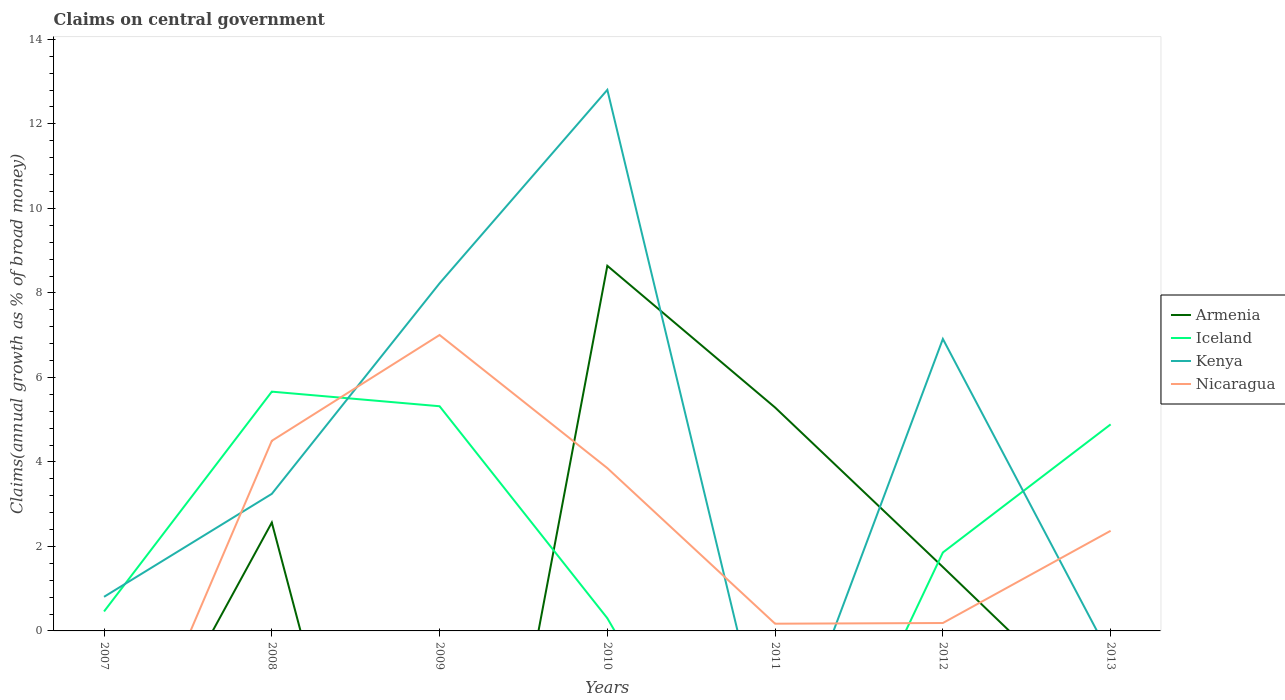How many different coloured lines are there?
Provide a succinct answer. 4. Across all years, what is the maximum percentage of broad money claimed on centeral government in Kenya?
Offer a terse response. 0. What is the total percentage of broad money claimed on centeral government in Nicaragua in the graph?
Your answer should be compact. -2.5. What is the difference between the highest and the second highest percentage of broad money claimed on centeral government in Iceland?
Offer a terse response. 5.66. Is the percentage of broad money claimed on centeral government in Kenya strictly greater than the percentage of broad money claimed on centeral government in Iceland over the years?
Give a very brief answer. No. How many lines are there?
Give a very brief answer. 4. How many years are there in the graph?
Make the answer very short. 7. What is the difference between two consecutive major ticks on the Y-axis?
Your answer should be very brief. 2. Are the values on the major ticks of Y-axis written in scientific E-notation?
Provide a succinct answer. No. Does the graph contain grids?
Give a very brief answer. No. How are the legend labels stacked?
Offer a very short reply. Vertical. What is the title of the graph?
Your response must be concise. Claims on central government. Does "Hungary" appear as one of the legend labels in the graph?
Your response must be concise. No. What is the label or title of the Y-axis?
Ensure brevity in your answer.  Claims(annual growth as % of broad money). What is the Claims(annual growth as % of broad money) in Iceland in 2007?
Offer a terse response. 0.46. What is the Claims(annual growth as % of broad money) in Kenya in 2007?
Offer a terse response. 0.81. What is the Claims(annual growth as % of broad money) in Armenia in 2008?
Keep it short and to the point. 2.57. What is the Claims(annual growth as % of broad money) in Iceland in 2008?
Offer a very short reply. 5.66. What is the Claims(annual growth as % of broad money) in Kenya in 2008?
Keep it short and to the point. 3.24. What is the Claims(annual growth as % of broad money) in Nicaragua in 2008?
Provide a short and direct response. 4.5. What is the Claims(annual growth as % of broad money) in Armenia in 2009?
Provide a short and direct response. 0. What is the Claims(annual growth as % of broad money) in Iceland in 2009?
Your answer should be very brief. 5.32. What is the Claims(annual growth as % of broad money) in Kenya in 2009?
Offer a very short reply. 8.23. What is the Claims(annual growth as % of broad money) in Nicaragua in 2009?
Give a very brief answer. 7. What is the Claims(annual growth as % of broad money) in Armenia in 2010?
Provide a short and direct response. 8.64. What is the Claims(annual growth as % of broad money) in Iceland in 2010?
Provide a succinct answer. 0.3. What is the Claims(annual growth as % of broad money) in Kenya in 2010?
Provide a succinct answer. 12.81. What is the Claims(annual growth as % of broad money) of Nicaragua in 2010?
Ensure brevity in your answer.  3.85. What is the Claims(annual growth as % of broad money) in Armenia in 2011?
Make the answer very short. 5.29. What is the Claims(annual growth as % of broad money) in Iceland in 2011?
Make the answer very short. 0. What is the Claims(annual growth as % of broad money) of Nicaragua in 2011?
Offer a terse response. 0.17. What is the Claims(annual growth as % of broad money) of Armenia in 2012?
Give a very brief answer. 1.51. What is the Claims(annual growth as % of broad money) in Iceland in 2012?
Your response must be concise. 1.86. What is the Claims(annual growth as % of broad money) of Kenya in 2012?
Ensure brevity in your answer.  6.91. What is the Claims(annual growth as % of broad money) of Nicaragua in 2012?
Provide a short and direct response. 0.19. What is the Claims(annual growth as % of broad money) in Armenia in 2013?
Offer a terse response. 0. What is the Claims(annual growth as % of broad money) in Iceland in 2013?
Your response must be concise. 4.89. What is the Claims(annual growth as % of broad money) in Nicaragua in 2013?
Provide a short and direct response. 2.37. Across all years, what is the maximum Claims(annual growth as % of broad money) of Armenia?
Your answer should be compact. 8.64. Across all years, what is the maximum Claims(annual growth as % of broad money) of Iceland?
Provide a succinct answer. 5.66. Across all years, what is the maximum Claims(annual growth as % of broad money) of Kenya?
Provide a succinct answer. 12.81. Across all years, what is the maximum Claims(annual growth as % of broad money) of Nicaragua?
Your response must be concise. 7. Across all years, what is the minimum Claims(annual growth as % of broad money) in Armenia?
Ensure brevity in your answer.  0. Across all years, what is the minimum Claims(annual growth as % of broad money) in Kenya?
Your answer should be compact. 0. What is the total Claims(annual growth as % of broad money) of Armenia in the graph?
Ensure brevity in your answer.  18.01. What is the total Claims(annual growth as % of broad money) of Iceland in the graph?
Provide a succinct answer. 18.49. What is the total Claims(annual growth as % of broad money) in Kenya in the graph?
Make the answer very short. 31.99. What is the total Claims(annual growth as % of broad money) of Nicaragua in the graph?
Your answer should be very brief. 18.08. What is the difference between the Claims(annual growth as % of broad money) of Iceland in 2007 and that in 2008?
Provide a short and direct response. -5.2. What is the difference between the Claims(annual growth as % of broad money) of Kenya in 2007 and that in 2008?
Make the answer very short. -2.44. What is the difference between the Claims(annual growth as % of broad money) in Iceland in 2007 and that in 2009?
Make the answer very short. -4.86. What is the difference between the Claims(annual growth as % of broad money) in Kenya in 2007 and that in 2009?
Make the answer very short. -7.42. What is the difference between the Claims(annual growth as % of broad money) of Iceland in 2007 and that in 2010?
Offer a very short reply. 0.16. What is the difference between the Claims(annual growth as % of broad money) in Kenya in 2007 and that in 2010?
Provide a succinct answer. -12. What is the difference between the Claims(annual growth as % of broad money) in Iceland in 2007 and that in 2012?
Offer a very short reply. -1.4. What is the difference between the Claims(annual growth as % of broad money) of Kenya in 2007 and that in 2012?
Make the answer very short. -6.1. What is the difference between the Claims(annual growth as % of broad money) in Iceland in 2007 and that in 2013?
Your response must be concise. -4.43. What is the difference between the Claims(annual growth as % of broad money) of Iceland in 2008 and that in 2009?
Provide a succinct answer. 0.35. What is the difference between the Claims(annual growth as % of broad money) of Kenya in 2008 and that in 2009?
Keep it short and to the point. -4.98. What is the difference between the Claims(annual growth as % of broad money) of Nicaragua in 2008 and that in 2009?
Give a very brief answer. -2.5. What is the difference between the Claims(annual growth as % of broad money) in Armenia in 2008 and that in 2010?
Make the answer very short. -6.08. What is the difference between the Claims(annual growth as % of broad money) of Iceland in 2008 and that in 2010?
Your answer should be compact. 5.36. What is the difference between the Claims(annual growth as % of broad money) in Kenya in 2008 and that in 2010?
Offer a terse response. -9.56. What is the difference between the Claims(annual growth as % of broad money) of Nicaragua in 2008 and that in 2010?
Provide a succinct answer. 0.65. What is the difference between the Claims(annual growth as % of broad money) in Armenia in 2008 and that in 2011?
Offer a very short reply. -2.72. What is the difference between the Claims(annual growth as % of broad money) in Nicaragua in 2008 and that in 2011?
Provide a succinct answer. 4.33. What is the difference between the Claims(annual growth as % of broad money) in Armenia in 2008 and that in 2012?
Offer a terse response. 1.05. What is the difference between the Claims(annual growth as % of broad money) of Iceland in 2008 and that in 2012?
Make the answer very short. 3.81. What is the difference between the Claims(annual growth as % of broad money) of Kenya in 2008 and that in 2012?
Provide a short and direct response. -3.67. What is the difference between the Claims(annual growth as % of broad money) in Nicaragua in 2008 and that in 2012?
Your answer should be compact. 4.31. What is the difference between the Claims(annual growth as % of broad money) in Iceland in 2008 and that in 2013?
Give a very brief answer. 0.77. What is the difference between the Claims(annual growth as % of broad money) in Nicaragua in 2008 and that in 2013?
Keep it short and to the point. 2.13. What is the difference between the Claims(annual growth as % of broad money) in Iceland in 2009 and that in 2010?
Offer a very short reply. 5.02. What is the difference between the Claims(annual growth as % of broad money) in Kenya in 2009 and that in 2010?
Your answer should be compact. -4.58. What is the difference between the Claims(annual growth as % of broad money) of Nicaragua in 2009 and that in 2010?
Give a very brief answer. 3.15. What is the difference between the Claims(annual growth as % of broad money) of Nicaragua in 2009 and that in 2011?
Ensure brevity in your answer.  6.83. What is the difference between the Claims(annual growth as % of broad money) of Iceland in 2009 and that in 2012?
Make the answer very short. 3.46. What is the difference between the Claims(annual growth as % of broad money) of Kenya in 2009 and that in 2012?
Your response must be concise. 1.32. What is the difference between the Claims(annual growth as % of broad money) of Nicaragua in 2009 and that in 2012?
Provide a succinct answer. 6.82. What is the difference between the Claims(annual growth as % of broad money) in Iceland in 2009 and that in 2013?
Ensure brevity in your answer.  0.43. What is the difference between the Claims(annual growth as % of broad money) of Nicaragua in 2009 and that in 2013?
Your answer should be compact. 4.63. What is the difference between the Claims(annual growth as % of broad money) of Armenia in 2010 and that in 2011?
Offer a very short reply. 3.35. What is the difference between the Claims(annual growth as % of broad money) of Nicaragua in 2010 and that in 2011?
Provide a short and direct response. 3.68. What is the difference between the Claims(annual growth as % of broad money) in Armenia in 2010 and that in 2012?
Provide a succinct answer. 7.13. What is the difference between the Claims(annual growth as % of broad money) of Iceland in 2010 and that in 2012?
Provide a succinct answer. -1.56. What is the difference between the Claims(annual growth as % of broad money) in Kenya in 2010 and that in 2012?
Offer a terse response. 5.9. What is the difference between the Claims(annual growth as % of broad money) in Nicaragua in 2010 and that in 2012?
Your response must be concise. 3.67. What is the difference between the Claims(annual growth as % of broad money) in Iceland in 2010 and that in 2013?
Your response must be concise. -4.59. What is the difference between the Claims(annual growth as % of broad money) in Nicaragua in 2010 and that in 2013?
Give a very brief answer. 1.48. What is the difference between the Claims(annual growth as % of broad money) of Armenia in 2011 and that in 2012?
Provide a succinct answer. 3.78. What is the difference between the Claims(annual growth as % of broad money) of Nicaragua in 2011 and that in 2012?
Your answer should be very brief. -0.02. What is the difference between the Claims(annual growth as % of broad money) in Nicaragua in 2011 and that in 2013?
Offer a very short reply. -2.2. What is the difference between the Claims(annual growth as % of broad money) of Iceland in 2012 and that in 2013?
Provide a short and direct response. -3.03. What is the difference between the Claims(annual growth as % of broad money) in Nicaragua in 2012 and that in 2013?
Ensure brevity in your answer.  -2.18. What is the difference between the Claims(annual growth as % of broad money) of Iceland in 2007 and the Claims(annual growth as % of broad money) of Kenya in 2008?
Keep it short and to the point. -2.78. What is the difference between the Claims(annual growth as % of broad money) in Iceland in 2007 and the Claims(annual growth as % of broad money) in Nicaragua in 2008?
Your response must be concise. -4.04. What is the difference between the Claims(annual growth as % of broad money) in Kenya in 2007 and the Claims(annual growth as % of broad money) in Nicaragua in 2008?
Make the answer very short. -3.69. What is the difference between the Claims(annual growth as % of broad money) in Iceland in 2007 and the Claims(annual growth as % of broad money) in Kenya in 2009?
Keep it short and to the point. -7.77. What is the difference between the Claims(annual growth as % of broad money) of Iceland in 2007 and the Claims(annual growth as % of broad money) of Nicaragua in 2009?
Keep it short and to the point. -6.54. What is the difference between the Claims(annual growth as % of broad money) in Kenya in 2007 and the Claims(annual growth as % of broad money) in Nicaragua in 2009?
Your answer should be very brief. -6.2. What is the difference between the Claims(annual growth as % of broad money) in Iceland in 2007 and the Claims(annual growth as % of broad money) in Kenya in 2010?
Offer a terse response. -12.35. What is the difference between the Claims(annual growth as % of broad money) in Iceland in 2007 and the Claims(annual growth as % of broad money) in Nicaragua in 2010?
Ensure brevity in your answer.  -3.39. What is the difference between the Claims(annual growth as % of broad money) in Kenya in 2007 and the Claims(annual growth as % of broad money) in Nicaragua in 2010?
Your answer should be compact. -3.05. What is the difference between the Claims(annual growth as % of broad money) of Iceland in 2007 and the Claims(annual growth as % of broad money) of Nicaragua in 2011?
Give a very brief answer. 0.29. What is the difference between the Claims(annual growth as % of broad money) of Kenya in 2007 and the Claims(annual growth as % of broad money) of Nicaragua in 2011?
Your answer should be very brief. 0.64. What is the difference between the Claims(annual growth as % of broad money) of Iceland in 2007 and the Claims(annual growth as % of broad money) of Kenya in 2012?
Your answer should be very brief. -6.45. What is the difference between the Claims(annual growth as % of broad money) in Iceland in 2007 and the Claims(annual growth as % of broad money) in Nicaragua in 2012?
Ensure brevity in your answer.  0.27. What is the difference between the Claims(annual growth as % of broad money) of Kenya in 2007 and the Claims(annual growth as % of broad money) of Nicaragua in 2012?
Make the answer very short. 0.62. What is the difference between the Claims(annual growth as % of broad money) of Iceland in 2007 and the Claims(annual growth as % of broad money) of Nicaragua in 2013?
Give a very brief answer. -1.91. What is the difference between the Claims(annual growth as % of broad money) of Kenya in 2007 and the Claims(annual growth as % of broad money) of Nicaragua in 2013?
Ensure brevity in your answer.  -1.56. What is the difference between the Claims(annual growth as % of broad money) of Armenia in 2008 and the Claims(annual growth as % of broad money) of Iceland in 2009?
Your response must be concise. -2.75. What is the difference between the Claims(annual growth as % of broad money) in Armenia in 2008 and the Claims(annual growth as % of broad money) in Kenya in 2009?
Provide a succinct answer. -5.66. What is the difference between the Claims(annual growth as % of broad money) of Armenia in 2008 and the Claims(annual growth as % of broad money) of Nicaragua in 2009?
Offer a terse response. -4.44. What is the difference between the Claims(annual growth as % of broad money) in Iceland in 2008 and the Claims(annual growth as % of broad money) in Kenya in 2009?
Your response must be concise. -2.56. What is the difference between the Claims(annual growth as % of broad money) of Iceland in 2008 and the Claims(annual growth as % of broad money) of Nicaragua in 2009?
Offer a terse response. -1.34. What is the difference between the Claims(annual growth as % of broad money) of Kenya in 2008 and the Claims(annual growth as % of broad money) of Nicaragua in 2009?
Make the answer very short. -3.76. What is the difference between the Claims(annual growth as % of broad money) in Armenia in 2008 and the Claims(annual growth as % of broad money) in Iceland in 2010?
Your response must be concise. 2.26. What is the difference between the Claims(annual growth as % of broad money) in Armenia in 2008 and the Claims(annual growth as % of broad money) in Kenya in 2010?
Your answer should be compact. -10.24. What is the difference between the Claims(annual growth as % of broad money) in Armenia in 2008 and the Claims(annual growth as % of broad money) in Nicaragua in 2010?
Offer a very short reply. -1.29. What is the difference between the Claims(annual growth as % of broad money) of Iceland in 2008 and the Claims(annual growth as % of broad money) of Kenya in 2010?
Provide a succinct answer. -7.14. What is the difference between the Claims(annual growth as % of broad money) in Iceland in 2008 and the Claims(annual growth as % of broad money) in Nicaragua in 2010?
Your answer should be compact. 1.81. What is the difference between the Claims(annual growth as % of broad money) in Kenya in 2008 and the Claims(annual growth as % of broad money) in Nicaragua in 2010?
Offer a very short reply. -0.61. What is the difference between the Claims(annual growth as % of broad money) in Armenia in 2008 and the Claims(annual growth as % of broad money) in Nicaragua in 2011?
Keep it short and to the point. 2.39. What is the difference between the Claims(annual growth as % of broad money) of Iceland in 2008 and the Claims(annual growth as % of broad money) of Nicaragua in 2011?
Your answer should be compact. 5.49. What is the difference between the Claims(annual growth as % of broad money) in Kenya in 2008 and the Claims(annual growth as % of broad money) in Nicaragua in 2011?
Give a very brief answer. 3.07. What is the difference between the Claims(annual growth as % of broad money) of Armenia in 2008 and the Claims(annual growth as % of broad money) of Iceland in 2012?
Your answer should be very brief. 0.71. What is the difference between the Claims(annual growth as % of broad money) in Armenia in 2008 and the Claims(annual growth as % of broad money) in Kenya in 2012?
Keep it short and to the point. -4.35. What is the difference between the Claims(annual growth as % of broad money) of Armenia in 2008 and the Claims(annual growth as % of broad money) of Nicaragua in 2012?
Keep it short and to the point. 2.38. What is the difference between the Claims(annual growth as % of broad money) of Iceland in 2008 and the Claims(annual growth as % of broad money) of Kenya in 2012?
Offer a very short reply. -1.25. What is the difference between the Claims(annual growth as % of broad money) in Iceland in 2008 and the Claims(annual growth as % of broad money) in Nicaragua in 2012?
Keep it short and to the point. 5.48. What is the difference between the Claims(annual growth as % of broad money) in Kenya in 2008 and the Claims(annual growth as % of broad money) in Nicaragua in 2012?
Keep it short and to the point. 3.06. What is the difference between the Claims(annual growth as % of broad money) in Armenia in 2008 and the Claims(annual growth as % of broad money) in Iceland in 2013?
Ensure brevity in your answer.  -2.32. What is the difference between the Claims(annual growth as % of broad money) of Armenia in 2008 and the Claims(annual growth as % of broad money) of Nicaragua in 2013?
Your answer should be very brief. 0.2. What is the difference between the Claims(annual growth as % of broad money) of Iceland in 2008 and the Claims(annual growth as % of broad money) of Nicaragua in 2013?
Your answer should be compact. 3.29. What is the difference between the Claims(annual growth as % of broad money) of Kenya in 2008 and the Claims(annual growth as % of broad money) of Nicaragua in 2013?
Your answer should be very brief. 0.87. What is the difference between the Claims(annual growth as % of broad money) of Iceland in 2009 and the Claims(annual growth as % of broad money) of Kenya in 2010?
Give a very brief answer. -7.49. What is the difference between the Claims(annual growth as % of broad money) of Iceland in 2009 and the Claims(annual growth as % of broad money) of Nicaragua in 2010?
Your answer should be very brief. 1.46. What is the difference between the Claims(annual growth as % of broad money) in Kenya in 2009 and the Claims(annual growth as % of broad money) in Nicaragua in 2010?
Provide a short and direct response. 4.37. What is the difference between the Claims(annual growth as % of broad money) in Iceland in 2009 and the Claims(annual growth as % of broad money) in Nicaragua in 2011?
Your response must be concise. 5.15. What is the difference between the Claims(annual growth as % of broad money) of Kenya in 2009 and the Claims(annual growth as % of broad money) of Nicaragua in 2011?
Offer a very short reply. 8.06. What is the difference between the Claims(annual growth as % of broad money) of Iceland in 2009 and the Claims(annual growth as % of broad money) of Kenya in 2012?
Provide a succinct answer. -1.59. What is the difference between the Claims(annual growth as % of broad money) in Iceland in 2009 and the Claims(annual growth as % of broad money) in Nicaragua in 2012?
Offer a very short reply. 5.13. What is the difference between the Claims(annual growth as % of broad money) of Kenya in 2009 and the Claims(annual growth as % of broad money) of Nicaragua in 2012?
Give a very brief answer. 8.04. What is the difference between the Claims(annual growth as % of broad money) in Iceland in 2009 and the Claims(annual growth as % of broad money) in Nicaragua in 2013?
Keep it short and to the point. 2.95. What is the difference between the Claims(annual growth as % of broad money) of Kenya in 2009 and the Claims(annual growth as % of broad money) of Nicaragua in 2013?
Your response must be concise. 5.86. What is the difference between the Claims(annual growth as % of broad money) in Armenia in 2010 and the Claims(annual growth as % of broad money) in Nicaragua in 2011?
Your response must be concise. 8.47. What is the difference between the Claims(annual growth as % of broad money) of Iceland in 2010 and the Claims(annual growth as % of broad money) of Nicaragua in 2011?
Provide a succinct answer. 0.13. What is the difference between the Claims(annual growth as % of broad money) of Kenya in 2010 and the Claims(annual growth as % of broad money) of Nicaragua in 2011?
Offer a very short reply. 12.63. What is the difference between the Claims(annual growth as % of broad money) of Armenia in 2010 and the Claims(annual growth as % of broad money) of Iceland in 2012?
Offer a terse response. 6.79. What is the difference between the Claims(annual growth as % of broad money) in Armenia in 2010 and the Claims(annual growth as % of broad money) in Kenya in 2012?
Your response must be concise. 1.73. What is the difference between the Claims(annual growth as % of broad money) of Armenia in 2010 and the Claims(annual growth as % of broad money) of Nicaragua in 2012?
Your answer should be very brief. 8.45. What is the difference between the Claims(annual growth as % of broad money) of Iceland in 2010 and the Claims(annual growth as % of broad money) of Kenya in 2012?
Keep it short and to the point. -6.61. What is the difference between the Claims(annual growth as % of broad money) in Iceland in 2010 and the Claims(annual growth as % of broad money) in Nicaragua in 2012?
Provide a succinct answer. 0.11. What is the difference between the Claims(annual growth as % of broad money) in Kenya in 2010 and the Claims(annual growth as % of broad money) in Nicaragua in 2012?
Give a very brief answer. 12.62. What is the difference between the Claims(annual growth as % of broad money) in Armenia in 2010 and the Claims(annual growth as % of broad money) in Iceland in 2013?
Your answer should be compact. 3.75. What is the difference between the Claims(annual growth as % of broad money) of Armenia in 2010 and the Claims(annual growth as % of broad money) of Nicaragua in 2013?
Your answer should be compact. 6.27. What is the difference between the Claims(annual growth as % of broad money) in Iceland in 2010 and the Claims(annual growth as % of broad money) in Nicaragua in 2013?
Your response must be concise. -2.07. What is the difference between the Claims(annual growth as % of broad money) of Kenya in 2010 and the Claims(annual growth as % of broad money) of Nicaragua in 2013?
Keep it short and to the point. 10.44. What is the difference between the Claims(annual growth as % of broad money) in Armenia in 2011 and the Claims(annual growth as % of broad money) in Iceland in 2012?
Offer a very short reply. 3.43. What is the difference between the Claims(annual growth as % of broad money) of Armenia in 2011 and the Claims(annual growth as % of broad money) of Kenya in 2012?
Offer a very short reply. -1.62. What is the difference between the Claims(annual growth as % of broad money) of Armenia in 2011 and the Claims(annual growth as % of broad money) of Nicaragua in 2012?
Your response must be concise. 5.1. What is the difference between the Claims(annual growth as % of broad money) of Armenia in 2011 and the Claims(annual growth as % of broad money) of Iceland in 2013?
Provide a short and direct response. 0.4. What is the difference between the Claims(annual growth as % of broad money) of Armenia in 2011 and the Claims(annual growth as % of broad money) of Nicaragua in 2013?
Your answer should be very brief. 2.92. What is the difference between the Claims(annual growth as % of broad money) in Armenia in 2012 and the Claims(annual growth as % of broad money) in Iceland in 2013?
Your response must be concise. -3.38. What is the difference between the Claims(annual growth as % of broad money) of Armenia in 2012 and the Claims(annual growth as % of broad money) of Nicaragua in 2013?
Your answer should be compact. -0.86. What is the difference between the Claims(annual growth as % of broad money) in Iceland in 2012 and the Claims(annual growth as % of broad money) in Nicaragua in 2013?
Offer a terse response. -0.51. What is the difference between the Claims(annual growth as % of broad money) in Kenya in 2012 and the Claims(annual growth as % of broad money) in Nicaragua in 2013?
Your answer should be very brief. 4.54. What is the average Claims(annual growth as % of broad money) of Armenia per year?
Offer a terse response. 2.57. What is the average Claims(annual growth as % of broad money) of Iceland per year?
Offer a very short reply. 2.64. What is the average Claims(annual growth as % of broad money) in Kenya per year?
Make the answer very short. 4.57. What is the average Claims(annual growth as % of broad money) in Nicaragua per year?
Provide a short and direct response. 2.58. In the year 2007, what is the difference between the Claims(annual growth as % of broad money) of Iceland and Claims(annual growth as % of broad money) of Kenya?
Your answer should be compact. -0.35. In the year 2008, what is the difference between the Claims(annual growth as % of broad money) in Armenia and Claims(annual growth as % of broad money) in Iceland?
Provide a succinct answer. -3.1. In the year 2008, what is the difference between the Claims(annual growth as % of broad money) of Armenia and Claims(annual growth as % of broad money) of Kenya?
Your answer should be compact. -0.68. In the year 2008, what is the difference between the Claims(annual growth as % of broad money) of Armenia and Claims(annual growth as % of broad money) of Nicaragua?
Your response must be concise. -1.93. In the year 2008, what is the difference between the Claims(annual growth as % of broad money) of Iceland and Claims(annual growth as % of broad money) of Kenya?
Provide a short and direct response. 2.42. In the year 2008, what is the difference between the Claims(annual growth as % of broad money) in Iceland and Claims(annual growth as % of broad money) in Nicaragua?
Your response must be concise. 1.16. In the year 2008, what is the difference between the Claims(annual growth as % of broad money) of Kenya and Claims(annual growth as % of broad money) of Nicaragua?
Offer a terse response. -1.26. In the year 2009, what is the difference between the Claims(annual growth as % of broad money) of Iceland and Claims(annual growth as % of broad money) of Kenya?
Offer a very short reply. -2.91. In the year 2009, what is the difference between the Claims(annual growth as % of broad money) in Iceland and Claims(annual growth as % of broad money) in Nicaragua?
Offer a very short reply. -1.69. In the year 2009, what is the difference between the Claims(annual growth as % of broad money) of Kenya and Claims(annual growth as % of broad money) of Nicaragua?
Provide a short and direct response. 1.22. In the year 2010, what is the difference between the Claims(annual growth as % of broad money) of Armenia and Claims(annual growth as % of broad money) of Iceland?
Provide a short and direct response. 8.34. In the year 2010, what is the difference between the Claims(annual growth as % of broad money) of Armenia and Claims(annual growth as % of broad money) of Kenya?
Make the answer very short. -4.16. In the year 2010, what is the difference between the Claims(annual growth as % of broad money) in Armenia and Claims(annual growth as % of broad money) in Nicaragua?
Provide a succinct answer. 4.79. In the year 2010, what is the difference between the Claims(annual growth as % of broad money) in Iceland and Claims(annual growth as % of broad money) in Kenya?
Keep it short and to the point. -12.51. In the year 2010, what is the difference between the Claims(annual growth as % of broad money) in Iceland and Claims(annual growth as % of broad money) in Nicaragua?
Give a very brief answer. -3.55. In the year 2010, what is the difference between the Claims(annual growth as % of broad money) in Kenya and Claims(annual growth as % of broad money) in Nicaragua?
Provide a short and direct response. 8.95. In the year 2011, what is the difference between the Claims(annual growth as % of broad money) in Armenia and Claims(annual growth as % of broad money) in Nicaragua?
Ensure brevity in your answer.  5.12. In the year 2012, what is the difference between the Claims(annual growth as % of broad money) in Armenia and Claims(annual growth as % of broad money) in Iceland?
Provide a succinct answer. -0.34. In the year 2012, what is the difference between the Claims(annual growth as % of broad money) in Armenia and Claims(annual growth as % of broad money) in Kenya?
Make the answer very short. -5.4. In the year 2012, what is the difference between the Claims(annual growth as % of broad money) in Armenia and Claims(annual growth as % of broad money) in Nicaragua?
Keep it short and to the point. 1.33. In the year 2012, what is the difference between the Claims(annual growth as % of broad money) of Iceland and Claims(annual growth as % of broad money) of Kenya?
Your answer should be very brief. -5.05. In the year 2012, what is the difference between the Claims(annual growth as % of broad money) in Iceland and Claims(annual growth as % of broad money) in Nicaragua?
Keep it short and to the point. 1.67. In the year 2012, what is the difference between the Claims(annual growth as % of broad money) of Kenya and Claims(annual growth as % of broad money) of Nicaragua?
Offer a terse response. 6.72. In the year 2013, what is the difference between the Claims(annual growth as % of broad money) of Iceland and Claims(annual growth as % of broad money) of Nicaragua?
Provide a succinct answer. 2.52. What is the ratio of the Claims(annual growth as % of broad money) of Iceland in 2007 to that in 2008?
Make the answer very short. 0.08. What is the ratio of the Claims(annual growth as % of broad money) in Kenya in 2007 to that in 2008?
Provide a succinct answer. 0.25. What is the ratio of the Claims(annual growth as % of broad money) of Iceland in 2007 to that in 2009?
Provide a short and direct response. 0.09. What is the ratio of the Claims(annual growth as % of broad money) in Kenya in 2007 to that in 2009?
Make the answer very short. 0.1. What is the ratio of the Claims(annual growth as % of broad money) in Iceland in 2007 to that in 2010?
Your answer should be very brief. 1.53. What is the ratio of the Claims(annual growth as % of broad money) of Kenya in 2007 to that in 2010?
Offer a terse response. 0.06. What is the ratio of the Claims(annual growth as % of broad money) in Iceland in 2007 to that in 2012?
Ensure brevity in your answer.  0.25. What is the ratio of the Claims(annual growth as % of broad money) of Kenya in 2007 to that in 2012?
Make the answer very short. 0.12. What is the ratio of the Claims(annual growth as % of broad money) in Iceland in 2007 to that in 2013?
Offer a terse response. 0.09. What is the ratio of the Claims(annual growth as % of broad money) of Iceland in 2008 to that in 2009?
Your response must be concise. 1.06. What is the ratio of the Claims(annual growth as % of broad money) of Kenya in 2008 to that in 2009?
Make the answer very short. 0.39. What is the ratio of the Claims(annual growth as % of broad money) in Nicaragua in 2008 to that in 2009?
Your response must be concise. 0.64. What is the ratio of the Claims(annual growth as % of broad money) in Armenia in 2008 to that in 2010?
Offer a terse response. 0.3. What is the ratio of the Claims(annual growth as % of broad money) in Iceland in 2008 to that in 2010?
Keep it short and to the point. 18.84. What is the ratio of the Claims(annual growth as % of broad money) of Kenya in 2008 to that in 2010?
Make the answer very short. 0.25. What is the ratio of the Claims(annual growth as % of broad money) in Nicaragua in 2008 to that in 2010?
Your answer should be compact. 1.17. What is the ratio of the Claims(annual growth as % of broad money) in Armenia in 2008 to that in 2011?
Your response must be concise. 0.49. What is the ratio of the Claims(annual growth as % of broad money) in Nicaragua in 2008 to that in 2011?
Ensure brevity in your answer.  26.34. What is the ratio of the Claims(annual growth as % of broad money) of Armenia in 2008 to that in 2012?
Provide a short and direct response. 1.7. What is the ratio of the Claims(annual growth as % of broad money) in Iceland in 2008 to that in 2012?
Ensure brevity in your answer.  3.05. What is the ratio of the Claims(annual growth as % of broad money) of Kenya in 2008 to that in 2012?
Provide a succinct answer. 0.47. What is the ratio of the Claims(annual growth as % of broad money) of Nicaragua in 2008 to that in 2012?
Ensure brevity in your answer.  24.04. What is the ratio of the Claims(annual growth as % of broad money) of Iceland in 2008 to that in 2013?
Provide a succinct answer. 1.16. What is the ratio of the Claims(annual growth as % of broad money) of Nicaragua in 2008 to that in 2013?
Provide a succinct answer. 1.9. What is the ratio of the Claims(annual growth as % of broad money) in Iceland in 2009 to that in 2010?
Offer a very short reply. 17.69. What is the ratio of the Claims(annual growth as % of broad money) in Kenya in 2009 to that in 2010?
Your answer should be very brief. 0.64. What is the ratio of the Claims(annual growth as % of broad money) of Nicaragua in 2009 to that in 2010?
Your response must be concise. 1.82. What is the ratio of the Claims(annual growth as % of broad money) of Nicaragua in 2009 to that in 2011?
Ensure brevity in your answer.  41. What is the ratio of the Claims(annual growth as % of broad money) in Iceland in 2009 to that in 2012?
Ensure brevity in your answer.  2.86. What is the ratio of the Claims(annual growth as % of broad money) of Kenya in 2009 to that in 2012?
Provide a succinct answer. 1.19. What is the ratio of the Claims(annual growth as % of broad money) of Nicaragua in 2009 to that in 2012?
Provide a succinct answer. 37.42. What is the ratio of the Claims(annual growth as % of broad money) of Iceland in 2009 to that in 2013?
Provide a short and direct response. 1.09. What is the ratio of the Claims(annual growth as % of broad money) in Nicaragua in 2009 to that in 2013?
Make the answer very short. 2.96. What is the ratio of the Claims(annual growth as % of broad money) of Armenia in 2010 to that in 2011?
Keep it short and to the point. 1.63. What is the ratio of the Claims(annual growth as % of broad money) of Nicaragua in 2010 to that in 2011?
Give a very brief answer. 22.56. What is the ratio of the Claims(annual growth as % of broad money) in Armenia in 2010 to that in 2012?
Make the answer very short. 5.71. What is the ratio of the Claims(annual growth as % of broad money) in Iceland in 2010 to that in 2012?
Keep it short and to the point. 0.16. What is the ratio of the Claims(annual growth as % of broad money) in Kenya in 2010 to that in 2012?
Your answer should be compact. 1.85. What is the ratio of the Claims(annual growth as % of broad money) of Nicaragua in 2010 to that in 2012?
Your answer should be compact. 20.59. What is the ratio of the Claims(annual growth as % of broad money) in Iceland in 2010 to that in 2013?
Give a very brief answer. 0.06. What is the ratio of the Claims(annual growth as % of broad money) of Nicaragua in 2010 to that in 2013?
Provide a short and direct response. 1.63. What is the ratio of the Claims(annual growth as % of broad money) of Armenia in 2011 to that in 2012?
Provide a succinct answer. 3.5. What is the ratio of the Claims(annual growth as % of broad money) in Nicaragua in 2011 to that in 2012?
Provide a succinct answer. 0.91. What is the ratio of the Claims(annual growth as % of broad money) in Nicaragua in 2011 to that in 2013?
Ensure brevity in your answer.  0.07. What is the ratio of the Claims(annual growth as % of broad money) of Iceland in 2012 to that in 2013?
Offer a terse response. 0.38. What is the ratio of the Claims(annual growth as % of broad money) of Nicaragua in 2012 to that in 2013?
Your answer should be very brief. 0.08. What is the difference between the highest and the second highest Claims(annual growth as % of broad money) in Armenia?
Your answer should be compact. 3.35. What is the difference between the highest and the second highest Claims(annual growth as % of broad money) in Iceland?
Your answer should be very brief. 0.35. What is the difference between the highest and the second highest Claims(annual growth as % of broad money) of Kenya?
Your response must be concise. 4.58. What is the difference between the highest and the second highest Claims(annual growth as % of broad money) in Nicaragua?
Give a very brief answer. 2.5. What is the difference between the highest and the lowest Claims(annual growth as % of broad money) in Armenia?
Your answer should be very brief. 8.64. What is the difference between the highest and the lowest Claims(annual growth as % of broad money) of Iceland?
Your answer should be compact. 5.66. What is the difference between the highest and the lowest Claims(annual growth as % of broad money) in Kenya?
Your answer should be compact. 12.81. What is the difference between the highest and the lowest Claims(annual growth as % of broad money) in Nicaragua?
Provide a succinct answer. 7. 